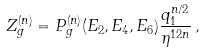Convert formula to latex. <formula><loc_0><loc_0><loc_500><loc_500>Z ^ { ( n ) } _ { g } = P ^ { ( n ) } _ { g } ( E _ { 2 } , E _ { 4 } , E _ { 6 } ) \frac { q _ { 1 } ^ { n / 2 } } { \eta ^ { 1 2 n } } \, ,</formula> 